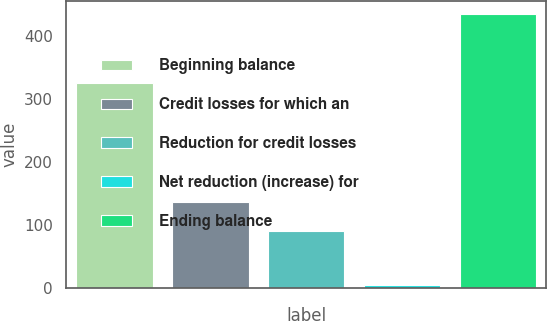<chart> <loc_0><loc_0><loc_500><loc_500><bar_chart><fcel>Beginning balance<fcel>Credit losses for which an<fcel>Reduction for credit losses<fcel>Net reduction (increase) for<fcel>Ending balance<nl><fcel>325.7<fcel>135.6<fcel>90.08<fcel>3.9<fcel>434.8<nl></chart> 